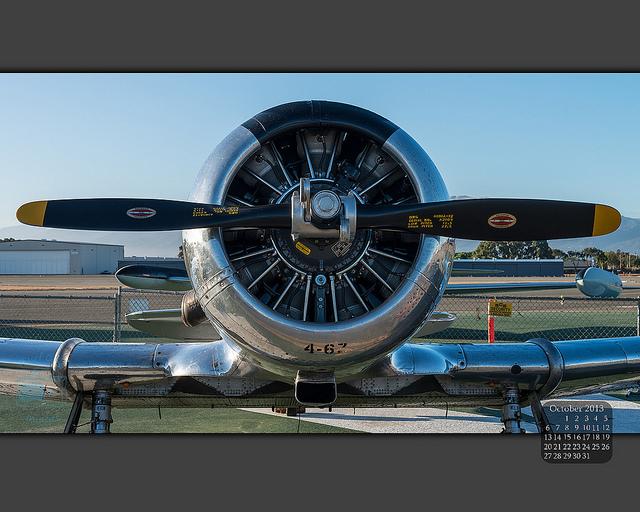Is this a jet airplane?
Give a very brief answer. Yes. What color is the propeller?
Give a very brief answer. Blue. Is this the kind of plane that the president might fly in?
Quick response, please. No. 